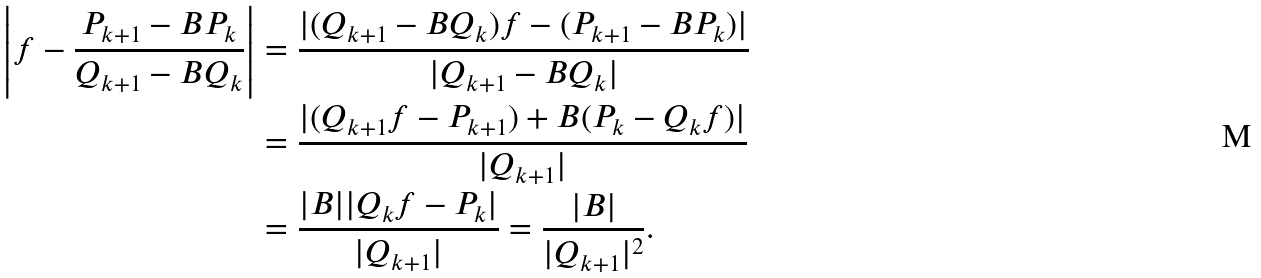Convert formula to latex. <formula><loc_0><loc_0><loc_500><loc_500>\left | f - \frac { P _ { k + 1 } - B P _ { k } } { Q _ { k + 1 } - B Q _ { k } } \right | & = \frac { | ( Q _ { k + 1 } - B Q _ { k } ) f - ( P _ { k + 1 } - B P _ { k } ) | } { | Q _ { k + 1 } - B Q _ { k } | } \\ & = \frac { | ( Q _ { k + 1 } f - P _ { k + 1 } ) + B ( P _ { k } - Q _ { k } f ) | } { | Q _ { k + 1 } | } \\ & = \frac { | B | | Q _ { k } f - P _ { k } | } { | Q _ { k + 1 } | } = \frac { | B | } { | Q _ { k + 1 } | ^ { 2 } } .</formula> 